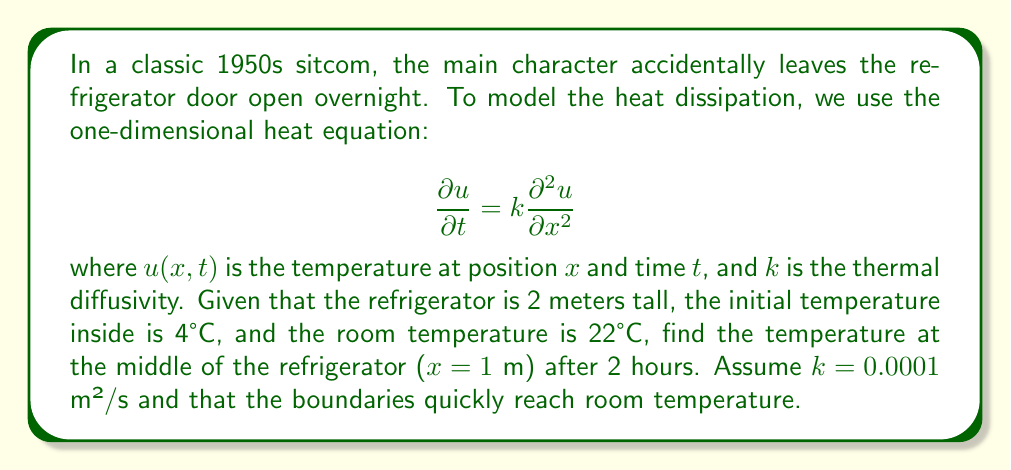Can you solve this math problem? To solve this problem, we'll use the solution to the heat equation for a finite rod with fixed boundary conditions:

1) The general solution is given by:
   $$u(x,t) = \sum_{n=1}^{\infty} B_n \sin(\frac{n\pi x}{L})e^{-k(\frac{n\pi}{L})^2t}$$

2) Where $L$ is the length of the rod (2 m in this case), and $B_n$ are coefficients determined by the initial conditions.

3) The initial condition is:
   $$u(x,0) = 4°C \text{ for } 0 < x < 2$$

4) The boundary conditions are:
   $$u(0,t) = u(2,t) = 22°C \text{ for } t > 0$$

5) To find $B_n$, we use:
   $$B_n = \frac{2}{L}\int_0^L [u(x,0) - 22] \sin(\frac{n\pi x}{L})dx$$

6) Solving this integral:
   $$B_n = \frac{2}{2}\int_0^2 [4 - 22] \sin(\frac{n\pi x}{2})dx = -18\frac{2}{n\pi}[1-(-1)^n]$$

7) Now, we can write our solution:
   $$u(x,t) = 22 - 36\sum_{n=1,3,5,...}^{\infty} \frac{1}{n\pi} \sin(\frac{n\pi x}{2})e^{-0.0001(\frac{n\pi}{2})^2t}$$

8) For x = 1 m and t = 2 hours = 7200 s:
   $$u(1,7200) = 22 - 36\sum_{n=1,3,5,...}^{\infty} \frac{1}{n\pi} \sin(\frac{n\pi}{2})e^{-0.0001(\frac{n\pi}{2})^2 7200}$$

9) Calculating the first few terms of this series (it converges quickly):
   $$u(1,7200) \approx 21.999°C$$
Answer: 21.999°C 